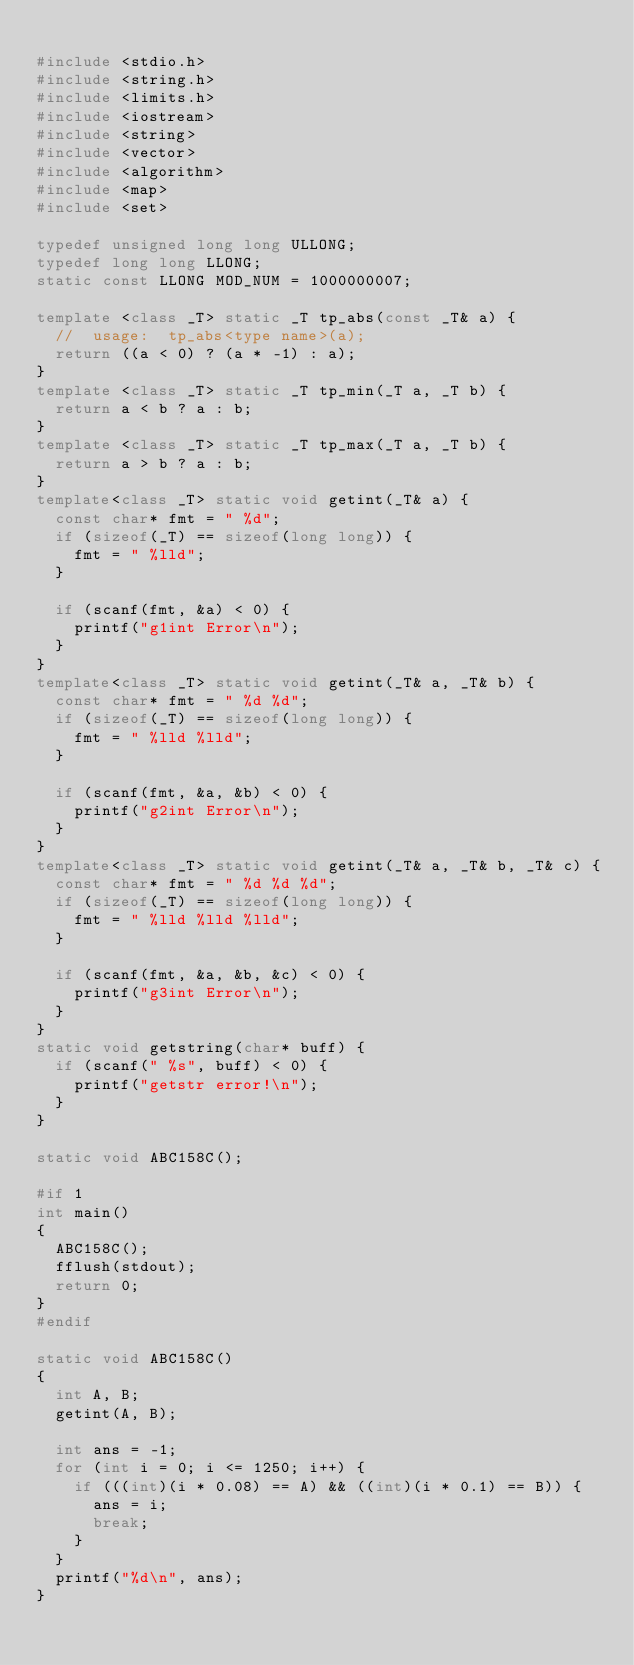Convert code to text. <code><loc_0><loc_0><loc_500><loc_500><_C++_>
#include <stdio.h>
#include <string.h>
#include <limits.h>
#include <iostream>
#include <string>
#include <vector>
#include <algorithm>
#include <map>
#include <set>

typedef unsigned long long ULLONG;
typedef long long LLONG;
static const LLONG MOD_NUM = 1000000007;

template <class _T> static _T tp_abs(const _T& a) {
	//	usage:  tp_abs<type name>(a);
	return ((a < 0) ? (a * -1) : a);
}
template <class _T> static _T tp_min(_T a, _T b) {
	return a < b ? a : b;
}
template <class _T> static _T tp_max(_T a, _T b) {
	return a > b ? a : b;
}
template<class _T> static void getint(_T& a) {
	const char* fmt = " %d";
	if (sizeof(_T) == sizeof(long long)) {
		fmt = " %lld";
	}

	if (scanf(fmt, &a) < 0) {
		printf("g1int Error\n");
	}
}
template<class _T> static void getint(_T& a, _T& b) {
	const char* fmt = " %d %d";
	if (sizeof(_T) == sizeof(long long)) {
		fmt = " %lld %lld";
	}

	if (scanf(fmt, &a, &b) < 0) {
		printf("g2int Error\n");
	}
}
template<class _T> static void getint(_T& a, _T& b, _T& c) {
	const char* fmt = " %d %d %d";
	if (sizeof(_T) == sizeof(long long)) {
		fmt = " %lld %lld %lld";
	}

	if (scanf(fmt, &a, &b, &c) < 0) {
		printf("g3int Error\n");
	}
}
static void getstring(char* buff) {
	if (scanf(" %s", buff) < 0) {
		printf("getstr error!\n");
	}
}

static void ABC158C();

#if 1
int main()
{
	ABC158C();
	fflush(stdout);
	return 0;
}
#endif

static void ABC158C()
{
	int A, B;
	getint(A, B);

	int ans = -1;
	for (int i = 0; i <= 1250; i++) {
		if (((int)(i * 0.08) == A) && ((int)(i * 0.1) == B)) {
			ans = i;
			break;
		}
	}
	printf("%d\n", ans);
}
</code> 